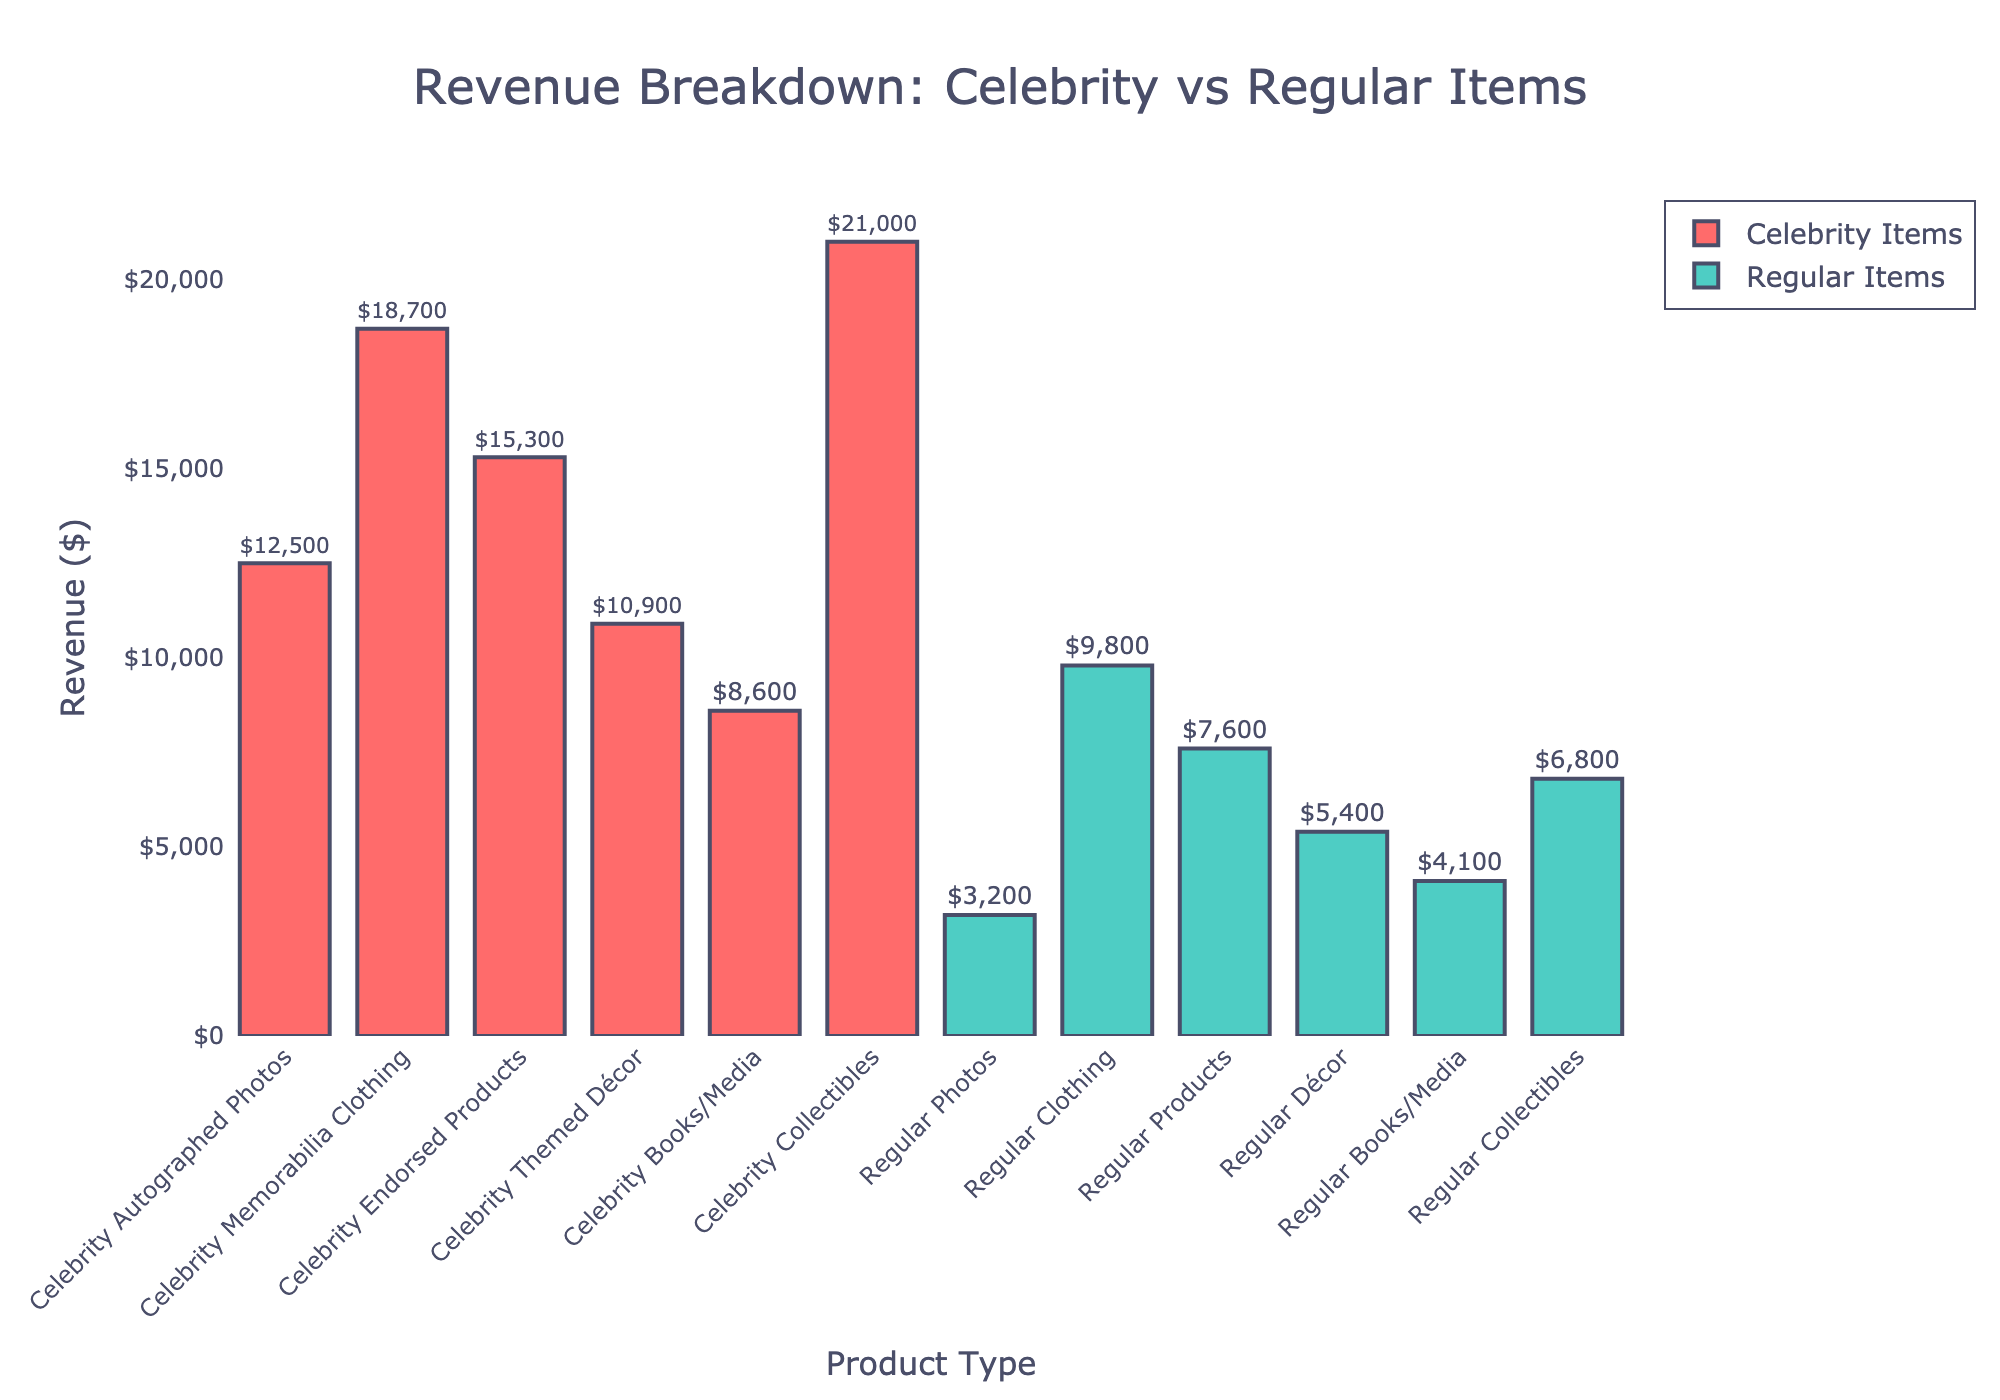Which product type generated the most revenue? To determine which product type generated the most revenue, look for the bar with the greatest height. The highest bar corresponds to "Celebrity Collectibles" with $21,000 in revenue.
Answer: Celebrity Collectibles Which product type generated more revenue: Celebrity Autographed Photos or Regular Photos? Compare the heights of the bars for "Celebrity Autographed Photos" and "Regular Photos". "Celebrity Autographed Photos" has a taller bar at $12,500, whereas "Regular Photos" has $3,200.
Answer: Celebrity Autographed Photos What is the total revenue generated from Regular Clothing and Celebrity Memorabilia Clothing? Add the revenues from "Regular Clothing" and "Celebrity Memorabilia Clothing". $9,800 (Regular Clothing) + $18,700 (Celebrity Memorabilia Clothing) = $28,500.
Answer: $28,500 Are there any categories where Regular items have more revenue than Celebrity items? Compare the heights of the bars for each product type. Regular items do not exceed Celebrity items in revenue in any category.
Answer: No By how much does the revenue of Celebrity Endorsed Products exceed Regular Products? Subtract the revenue of Regular Products from Celebrity Endorsed Products. $15,300 (Celebrity Endorsed Products) - $7,600 (Regular Products) = $7,700.
Answer: $7,700 Which category has the smallest difference in revenue between Celebrity and Regular items? Calculate the absolute difference in revenue for each category and identify the lowest value. For "Books/Media", the difference is $8,600 - $4,100 = $4,500 which is smaller than other categories.
Answer: Books/Media Which has more revenue: the sum of all Regular items or the sum of all Celebrity items? Calculate the total revenue for both, sum of Regular items: $3,200 + $9,800 + $7,600 + $5,400 + $4,100 + $6,800 = $36,900 and sum of Celebrity items: $12,500 + $18,700 + $15,300 + $10,900 + $8,600 + $21,000 = $87,000. Compare sums: $87,000 (Celebrity) > $36,900 (Regular).
Answer: Celebrity items What is the average revenue for all Celebrity items? Add the revenues for all Celebrity items and divide by the number of categories: ($12,500 + $18,700 + $15,300 + $10,900 + $8,600 + $21,000)/6 = $87,000/6 = $14,500.
Answer: $14,500 How does the revenue of Celebrity Themed Décor compare to the revenue of Regular Books/Media? Compare the heights of the bars for "Celebrity Themed Décor" and "Regular Books/Media". "Celebrity Themed Décor" generates $10,900 while "Regular Books/Media" generates $4,100.
Answer: Celebrity Themed Décor is higher 